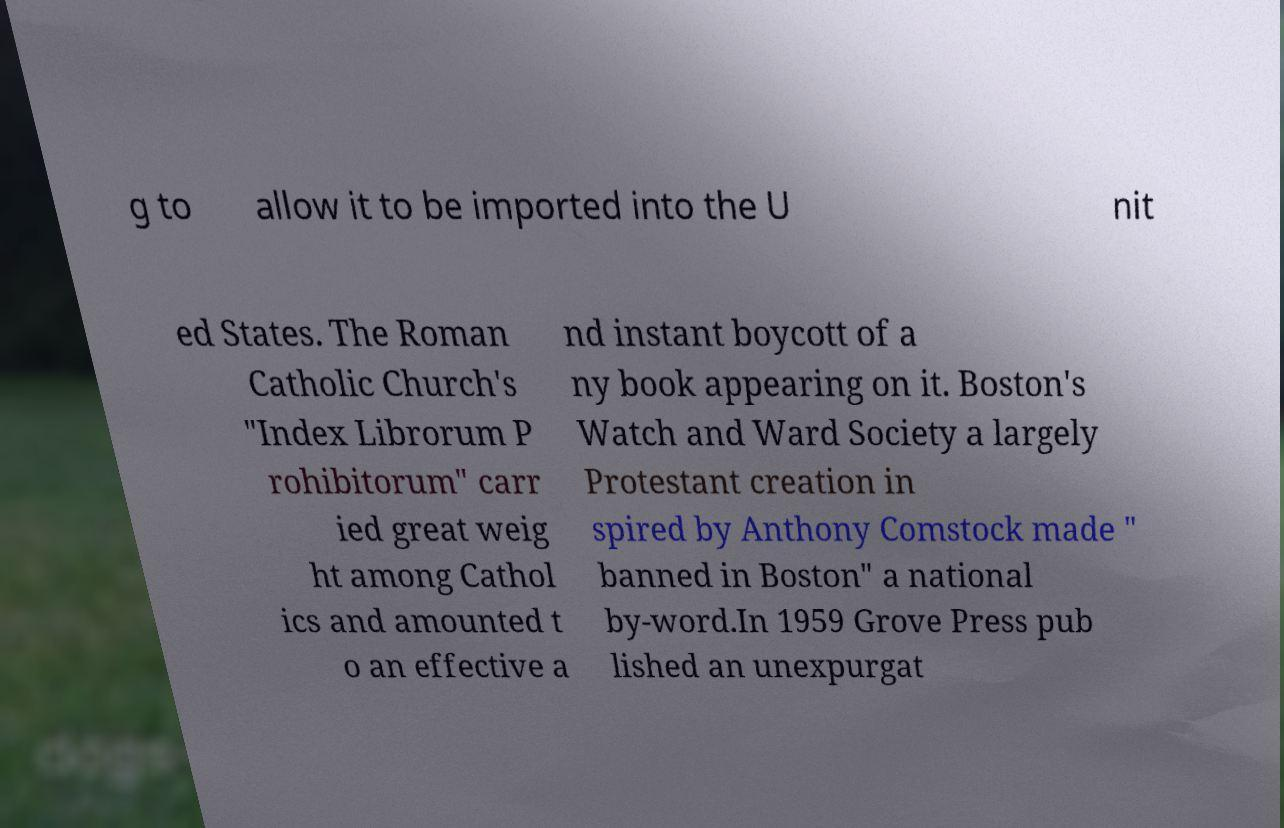Can you read and provide the text displayed in the image?This photo seems to have some interesting text. Can you extract and type it out for me? g to allow it to be imported into the U nit ed States. The Roman Catholic Church's "Index Librorum P rohibitorum" carr ied great weig ht among Cathol ics and amounted t o an effective a nd instant boycott of a ny book appearing on it. Boston's Watch and Ward Society a largely Protestant creation in spired by Anthony Comstock made " banned in Boston" a national by-word.In 1959 Grove Press pub lished an unexpurgat 